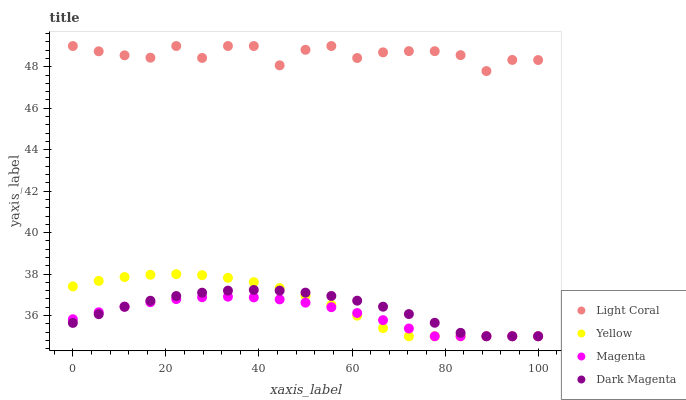Does Magenta have the minimum area under the curve?
Answer yes or no. Yes. Does Light Coral have the maximum area under the curve?
Answer yes or no. Yes. Does Dark Magenta have the minimum area under the curve?
Answer yes or no. No. Does Dark Magenta have the maximum area under the curve?
Answer yes or no. No. Is Magenta the smoothest?
Answer yes or no. Yes. Is Light Coral the roughest?
Answer yes or no. Yes. Is Dark Magenta the smoothest?
Answer yes or no. No. Is Dark Magenta the roughest?
Answer yes or no. No. Does Magenta have the lowest value?
Answer yes or no. Yes. Does Light Coral have the highest value?
Answer yes or no. Yes. Does Dark Magenta have the highest value?
Answer yes or no. No. Is Magenta less than Light Coral?
Answer yes or no. Yes. Is Light Coral greater than Yellow?
Answer yes or no. Yes. Does Yellow intersect Dark Magenta?
Answer yes or no. Yes. Is Yellow less than Dark Magenta?
Answer yes or no. No. Is Yellow greater than Dark Magenta?
Answer yes or no. No. Does Magenta intersect Light Coral?
Answer yes or no. No. 